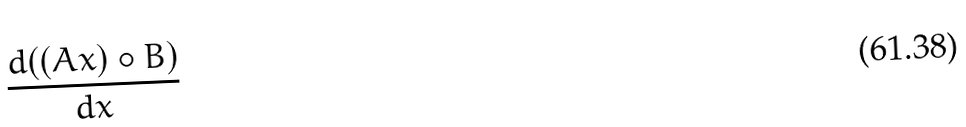<formula> <loc_0><loc_0><loc_500><loc_500>\frac { d ( ( A x ) \circ B ) } { d x }</formula> 